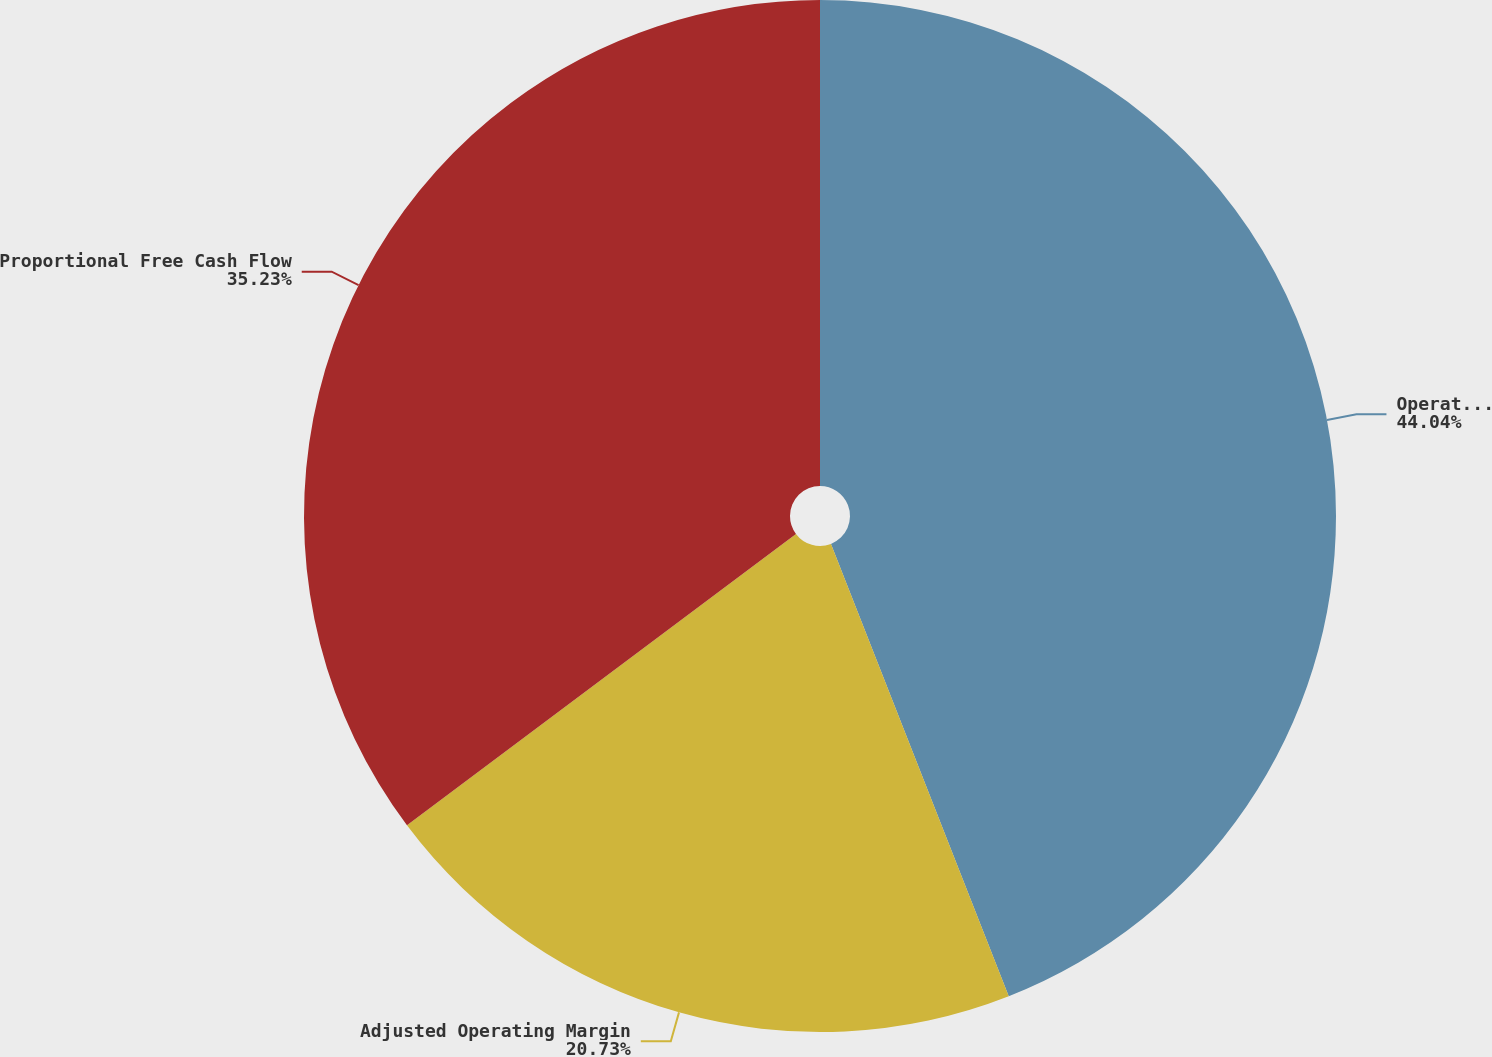Convert chart. <chart><loc_0><loc_0><loc_500><loc_500><pie_chart><fcel>Operating Margin<fcel>Adjusted Operating Margin<fcel>Proportional Free Cash Flow<nl><fcel>44.04%<fcel>20.73%<fcel>35.23%<nl></chart> 